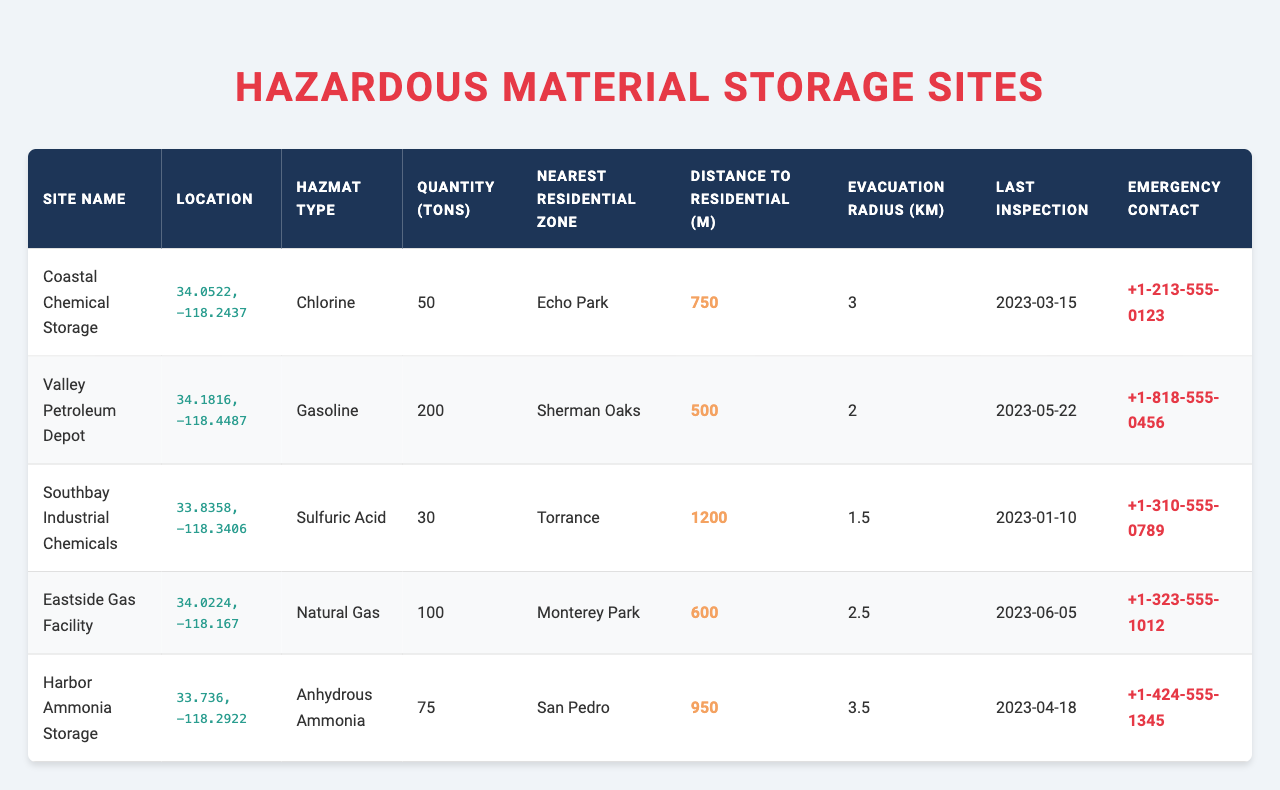What is the type of hazardous material stored at the Coastal Chemical Storage site? By looking at the details for the Coastal Chemical Storage in the table, the specified hazardous material type is listed directly in the hazmat type column, which shows "Chlorine."
Answer: Chlorine Which site has the highest quantity of hazardous material in tons? The table presents the quantities of hazardous materials for each site. By comparing these quantities, Valley Petroleum Depot has the highest quantity at 200 tons.
Answer: 200 tons Is there a hazardous material storage site that is closer than 600 meters to a residential zone? Reviewing the distance to residential zones in the table, both Valley Petroleum Depot (500 m) and Eastside Gas Facility (600 m) are closer than 600 meters to their nearest residential zones.
Answer: Yes What is the evacuation radius for Harbor Ammonia Storage? The evacuation radius for Harbor Ammonia Storage can be found directly in the respective column of the table, which states it is 3.5 kilometers.
Answer: 3.5 km How far is Southbay Industrial Chemicals from the nearest residential zone compared to Coastal Chemical Storage? The distances to the nearest residential zones are 1200 meters for Southbay Industrial Chemicals and 750 meters for Coastal Chemical Storage. To determine which is farther, we can conclude that Southbay Industrial Chemicals is farther by subtracting 750 from 1200, giving us 450 meters.
Answer: Southbay is farther by 450 meters What was the last inspection date for the Eastside Gas Facility? The last inspection date for the Eastside Gas Facility is mentioned in the table under the last inspection date column, which states it was conducted on June 5, 2023.
Answer: June 5, 2023 If we average the evacuation radii of all sites, what would that be? To find the average evacuation radius: (3 + 2 + 1.5 + 2.5 + 3.5) = 12 and then divide by the number of sites (5), giving us 12/5 = 2.4 kilometers.
Answer: 2.4 km Which site has the longest distance to its nearest residential zone? By examining the distance to residential zones, Southbay Industrial Chemicals has a distance of 1200 meters, which is the longest compared to the other sites listed.
Answer: Southbay Industrial Chemicals Is there an emergency contact available for all the sites listed? The table provides an emergency contact number for each storage site, confirming that yes, there is a contact available for all of them.
Answer: Yes Which hazardous material type has the highest quantity and which site stores it? The information in the table indicates that the type "Gasoline" has the highest quantity of 200 tons stored at the Valley Petroleum Depot.
Answer: Gasoline at Valley Petroleum Depot 